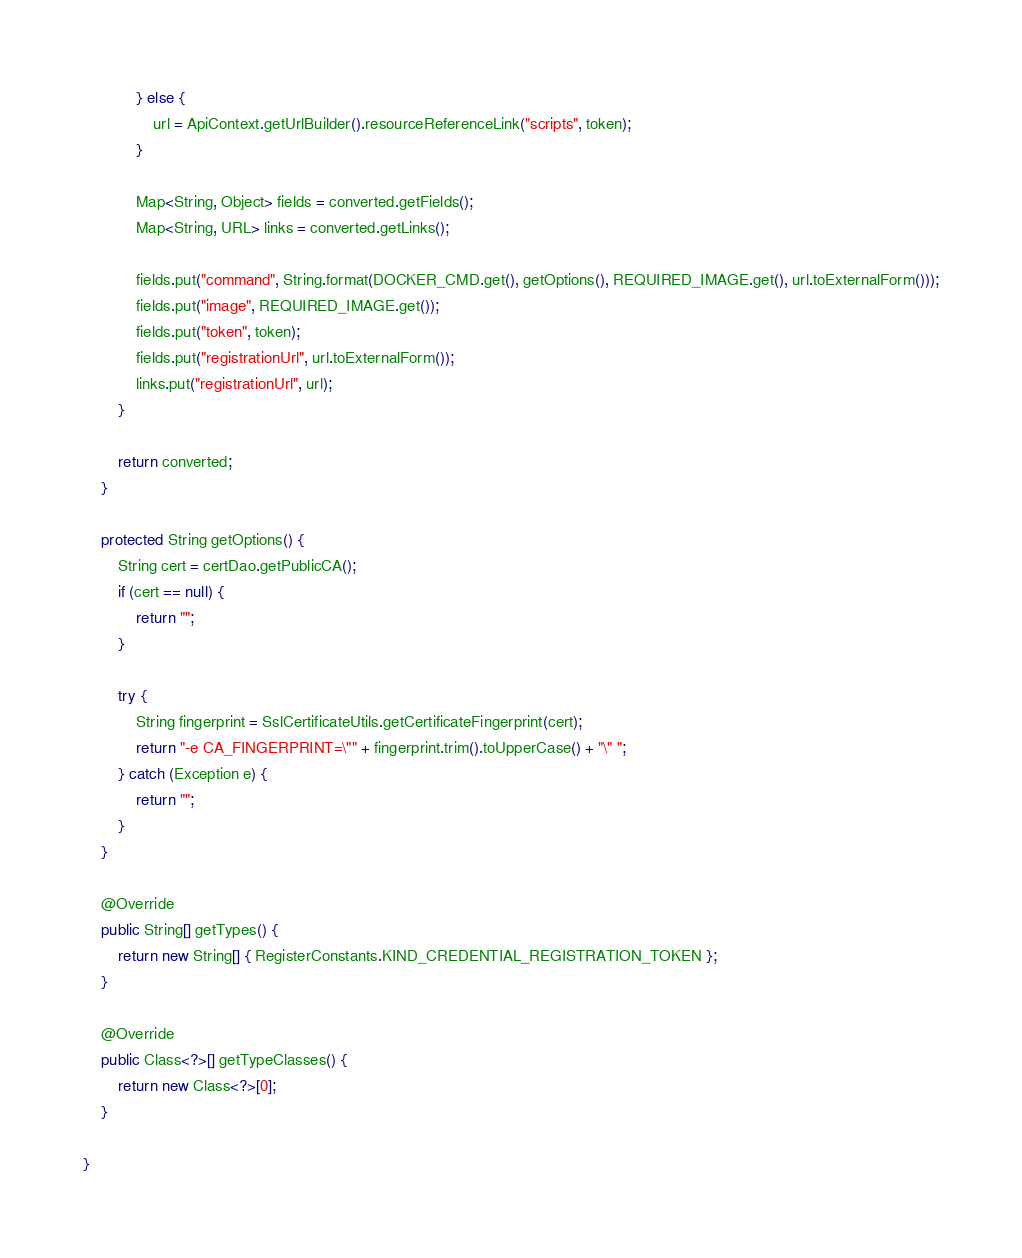Convert code to text. <code><loc_0><loc_0><loc_500><loc_500><_Java_>            } else {
                url = ApiContext.getUrlBuilder().resourceReferenceLink("scripts", token);
            }

            Map<String, Object> fields = converted.getFields();
            Map<String, URL> links = converted.getLinks();

            fields.put("command", String.format(DOCKER_CMD.get(), getOptions(), REQUIRED_IMAGE.get(), url.toExternalForm()));
            fields.put("image", REQUIRED_IMAGE.get());
            fields.put("token", token);
            fields.put("registrationUrl", url.toExternalForm());
            links.put("registrationUrl", url);
        }

        return converted;
    }

    protected String getOptions() {
        String cert = certDao.getPublicCA();
        if (cert == null) {
            return "";
        }

        try {
            String fingerprint = SslCertificateUtils.getCertificateFingerprint(cert);
            return "-e CA_FINGERPRINT=\"" + fingerprint.trim().toUpperCase() + "\" ";
        } catch (Exception e) {
            return "";
        }
    }

    @Override
    public String[] getTypes() {
        return new String[] { RegisterConstants.KIND_CREDENTIAL_REGISTRATION_TOKEN };
    }

    @Override
    public Class<?>[] getTypeClasses() {
        return new Class<?>[0];
    }

}
</code> 